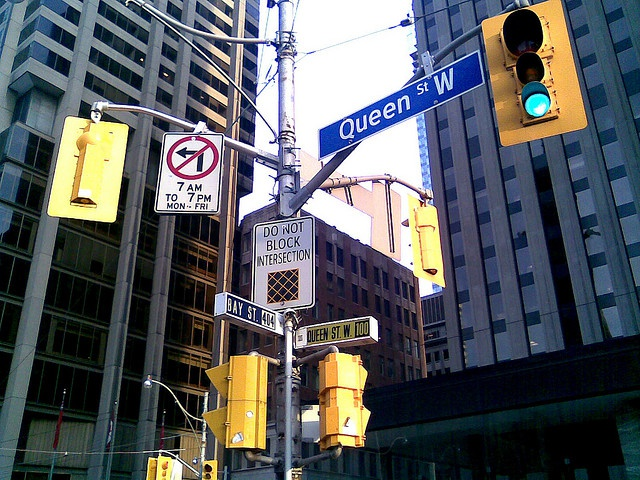Describe the objects in this image and their specific colors. I can see traffic light in darkblue, gold, orange, and olive tones, traffic light in darkblue, black, gold, maroon, and orange tones, traffic light in darkblue, khaki, and orange tones, traffic light in darkblue, khaki, beige, and tan tones, and traffic light in darkblue, khaki, orange, and beige tones in this image. 